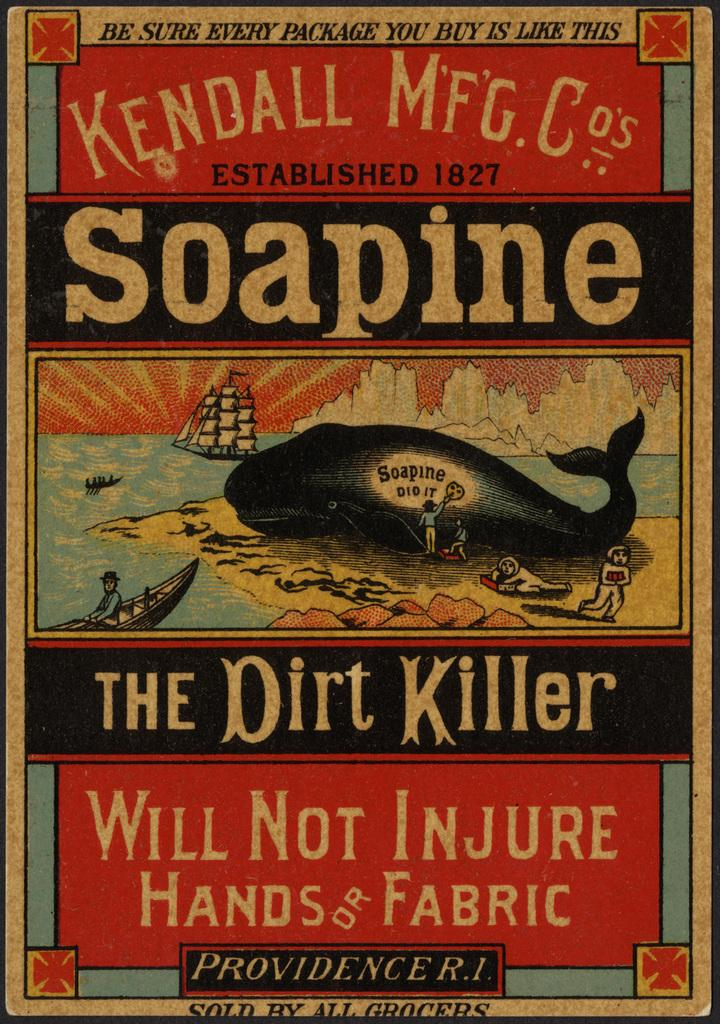<image>
Summarize the visual content of the image. a paper with a boat and the dirt killer on it 